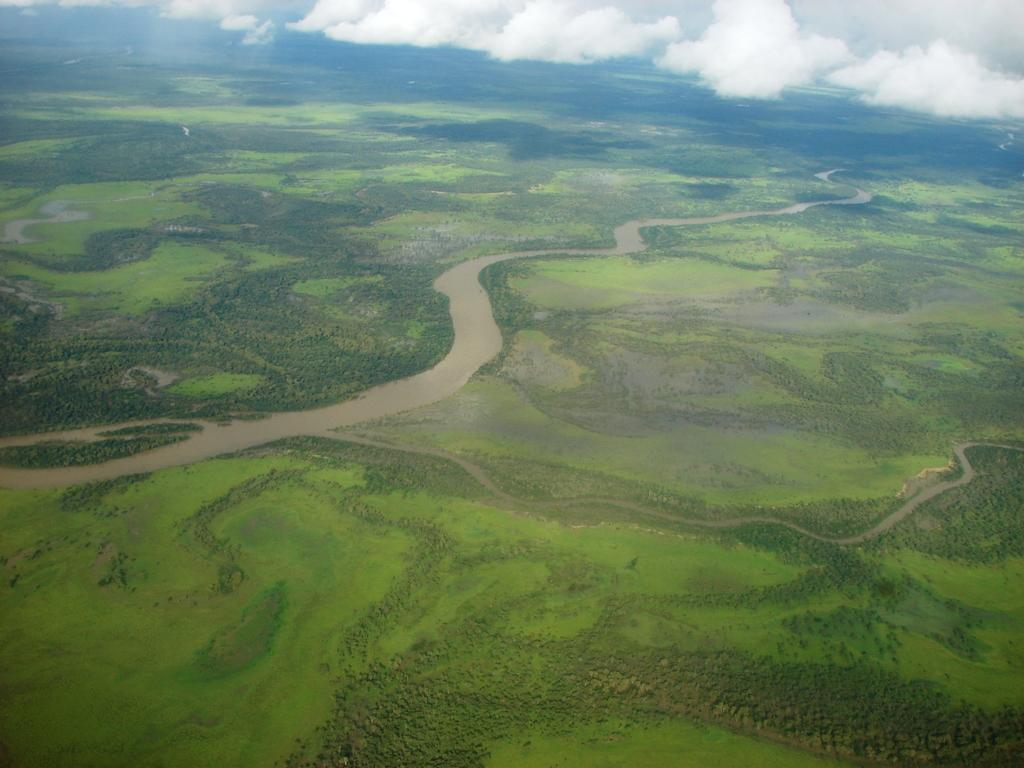What is the main feature in the center of the image? There is a canal in the center of the image. What can be seen in the sky in the image? There are clouds visible at the top of the image. What type of vegetation is present in the image? There are trees in the image. What type of rice is being harvested in the image? There is no rice or harvesting activity present in the image. What type of coach is visible in the image? There is no coach present in the image. 